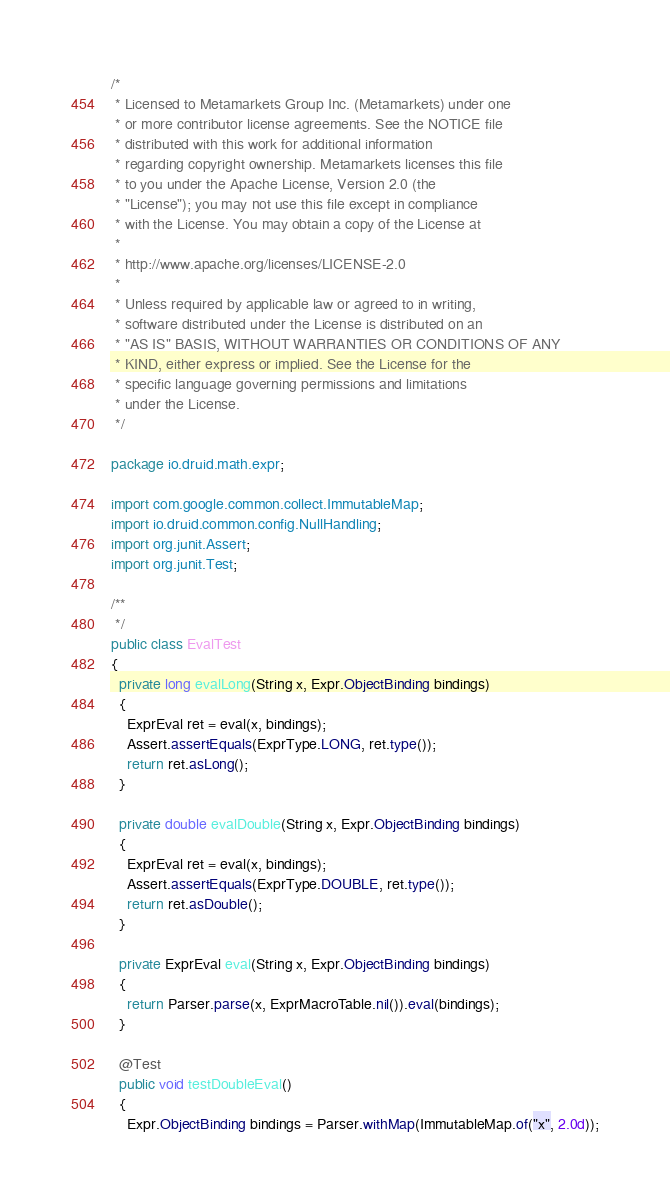<code> <loc_0><loc_0><loc_500><loc_500><_Java_>/*
 * Licensed to Metamarkets Group Inc. (Metamarkets) under one
 * or more contributor license agreements. See the NOTICE file
 * distributed with this work for additional information
 * regarding copyright ownership. Metamarkets licenses this file
 * to you under the Apache License, Version 2.0 (the
 * "License"); you may not use this file except in compliance
 * with the License. You may obtain a copy of the License at
 *
 * http://www.apache.org/licenses/LICENSE-2.0
 *
 * Unless required by applicable law or agreed to in writing,
 * software distributed under the License is distributed on an
 * "AS IS" BASIS, WITHOUT WARRANTIES OR CONDITIONS OF ANY
 * KIND, either express or implied. See the License for the
 * specific language governing permissions and limitations
 * under the License.
 */

package io.druid.math.expr;

import com.google.common.collect.ImmutableMap;
import io.druid.common.config.NullHandling;
import org.junit.Assert;
import org.junit.Test;

/**
 */
public class EvalTest
{
  private long evalLong(String x, Expr.ObjectBinding bindings)
  {
    ExprEval ret = eval(x, bindings);
    Assert.assertEquals(ExprType.LONG, ret.type());
    return ret.asLong();
  }

  private double evalDouble(String x, Expr.ObjectBinding bindings)
  {
    ExprEval ret = eval(x, bindings);
    Assert.assertEquals(ExprType.DOUBLE, ret.type());
    return ret.asDouble();
  }

  private ExprEval eval(String x, Expr.ObjectBinding bindings)
  {
    return Parser.parse(x, ExprMacroTable.nil()).eval(bindings);
  }

  @Test
  public void testDoubleEval()
  {
    Expr.ObjectBinding bindings = Parser.withMap(ImmutableMap.of("x", 2.0d));</code> 